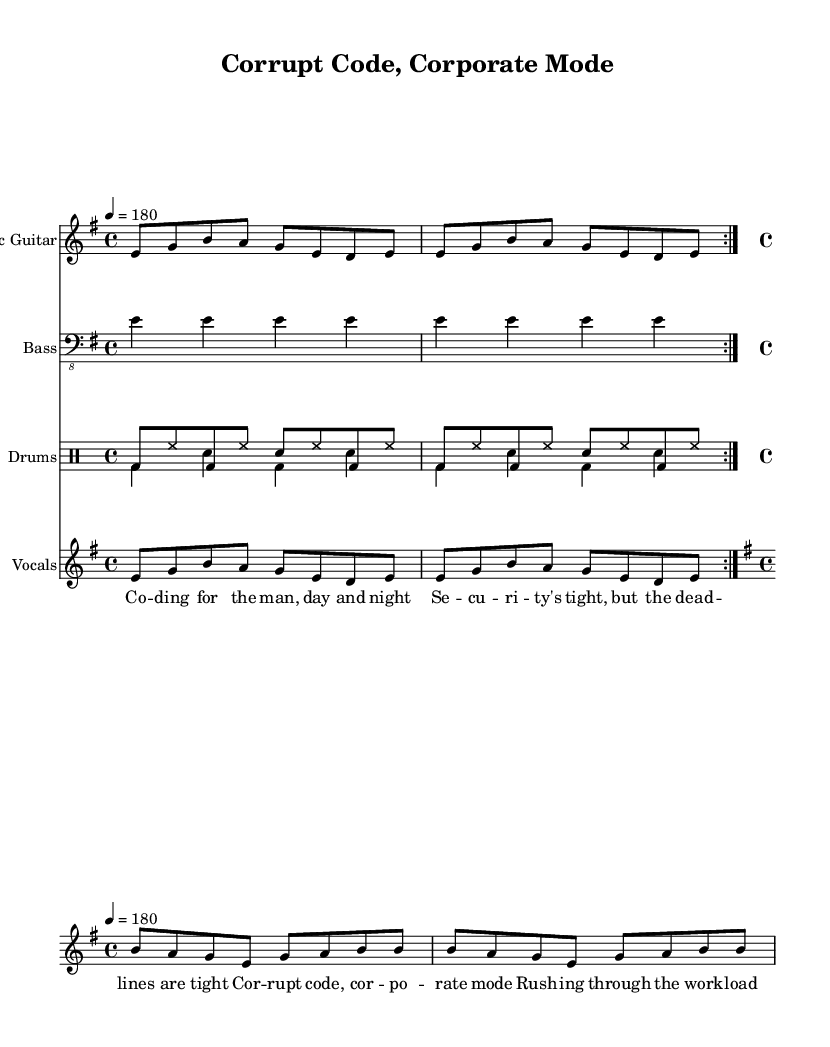What is the key signature of this music? The key signature is e minor, which has one sharp (F#). The key signature can be identified by looking at the beginning of the staff, where the sharps or flats are indicated.
Answer: e minor What is the time signature of this music? The time signature is 4/4, denoting four beats per measure. This can be found near the beginning of the sheet music where the time signature is displayed.
Answer: 4/4 What is the tempo marking for this piece? The tempo marking is 180 beats per minute, indicated by the tempo directive found in the header section of the score.
Answer: 180 How many repetitions are indicated in the guitar part? The guitar part indicates two repetitions (volta 2), which is revealed by the repeated section marking showing the 'volta' term in the music notation.
Answer: 2 What are the primary themes expressed in the lyrics? The lyrics express themes of corruption and corporate control, as highlighted in lines like "Corrupt code, corporate mode" and "security's tight." This can be interpreted from the content of the lyrics provided.
Answer: Corruption, corporate control What is the role of the bass guitar in this music? The bass guitar plays a steady rhythm of E notes, contributing to the foundational harmony and rhythmic structure of the piece. This is evident from the music notation where it plays repeated E notes.
Answer: Steady rhythm of E How do the vocal melodies differ between the verse and chorus? The vocal melodies differ in pitch range and rhythm, with the verse being in a lower register and the chorus featuring a more pronounced and higher melodic line. This can be discerned by comparing the notated pitches in each section.
Answer: Verse lower, chorus higher 